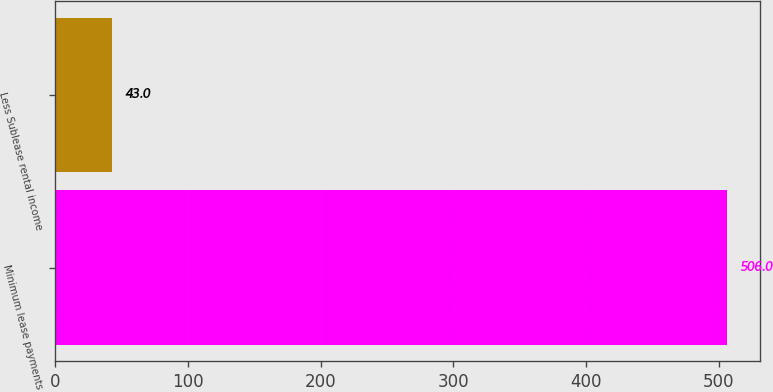Convert chart to OTSL. <chart><loc_0><loc_0><loc_500><loc_500><bar_chart><fcel>Minimum lease payments<fcel>Less Sublease rental income<nl><fcel>506<fcel>43<nl></chart> 